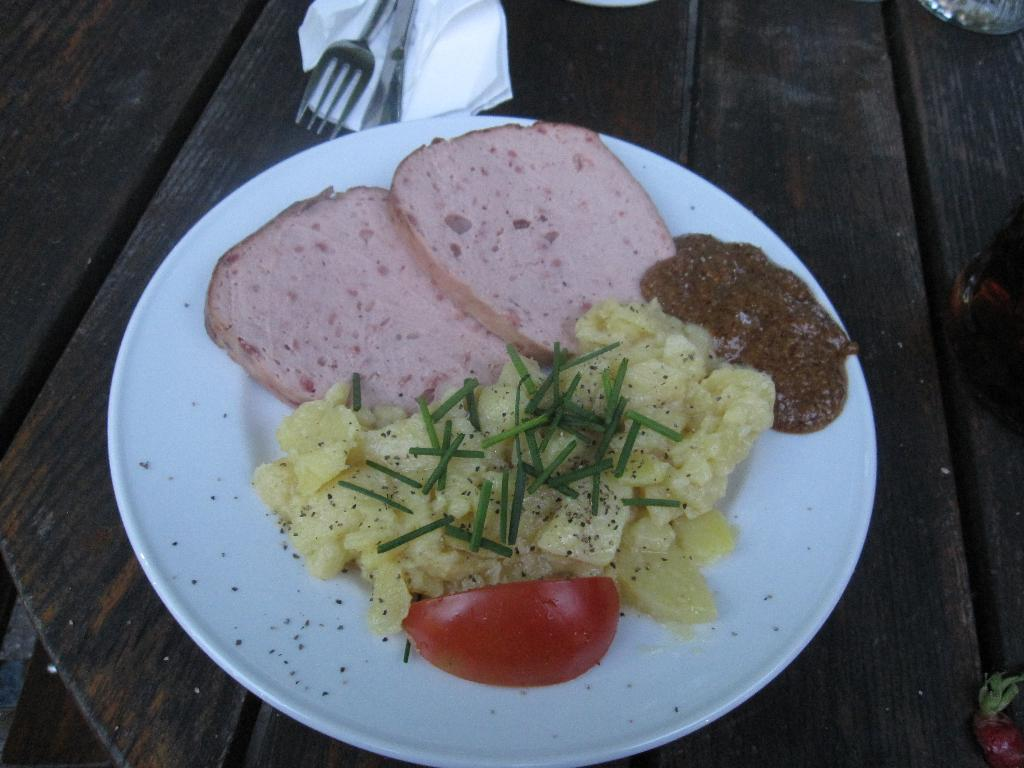What is on the white plate in the image? There are food items on a white plate in the image. What utensils are present in the image? There is a fork and a knife in the image. What might be used for cleaning or wiping in the image? There is a napkin in the image for cleaning or wiping. What type of surface is visible in the image? The wooden surface is present in the image. How many cows are visible in the image? There are no cows present in the image. Where is the faucet located in the image? There is no faucet present in the image. 